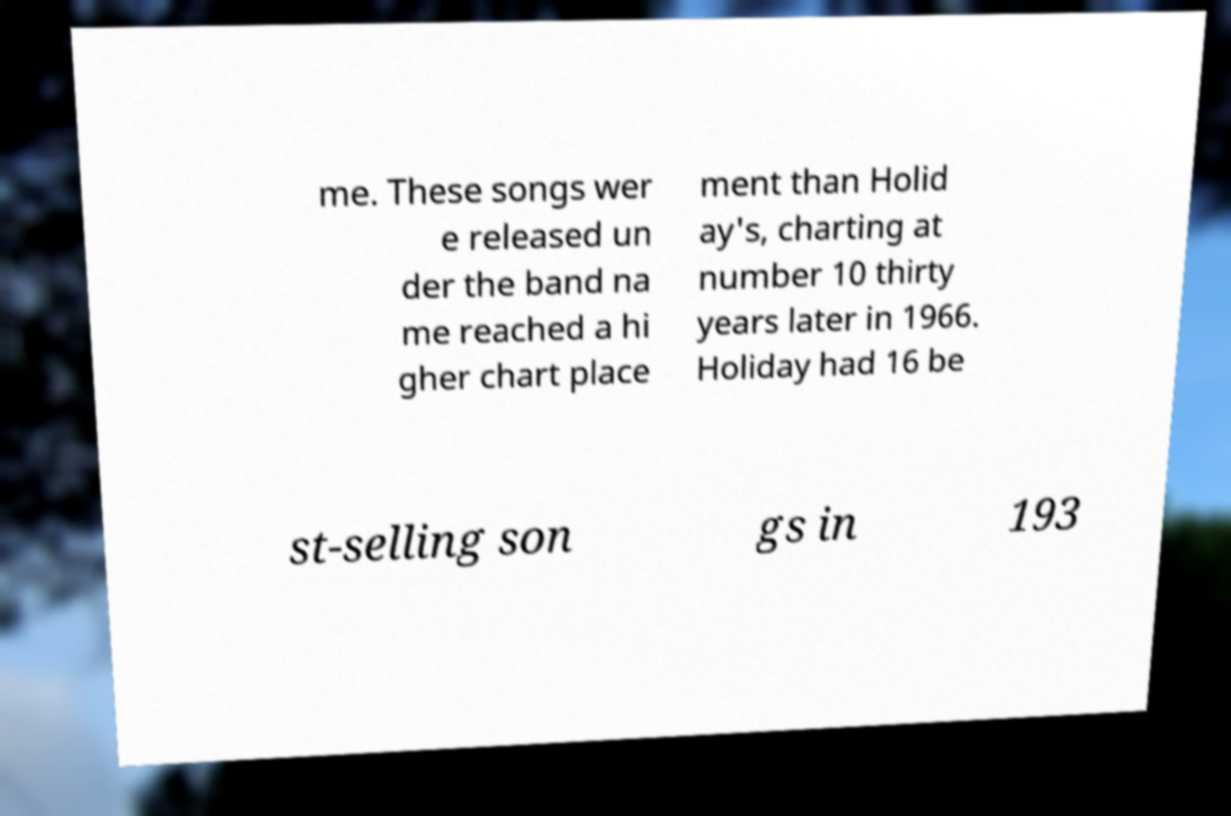I need the written content from this picture converted into text. Can you do that? me. These songs wer e released un der the band na me reached a hi gher chart place ment than Holid ay's, charting at number 10 thirty years later in 1966. Holiday had 16 be st-selling son gs in 193 